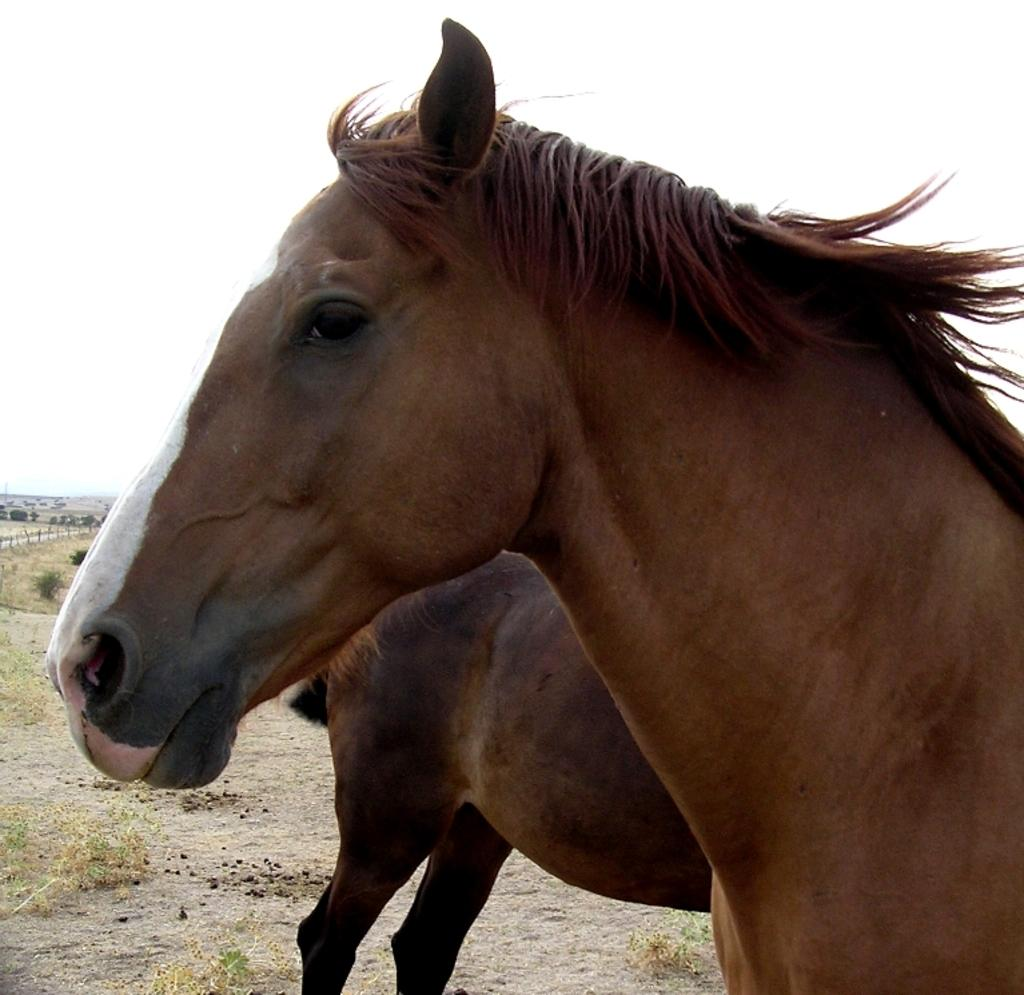What animals can be seen on the ground in the image? There are two horses on the ground in the image. What part of the natural environment is visible in the image? The sky is visible in the background of the image. What decision did the horses make in the image? There is no indication in the image that the horses made any decisions. What experience can be seen on the horses' faces in the image? There is no information about the horses' expressions or experiences in the image. 